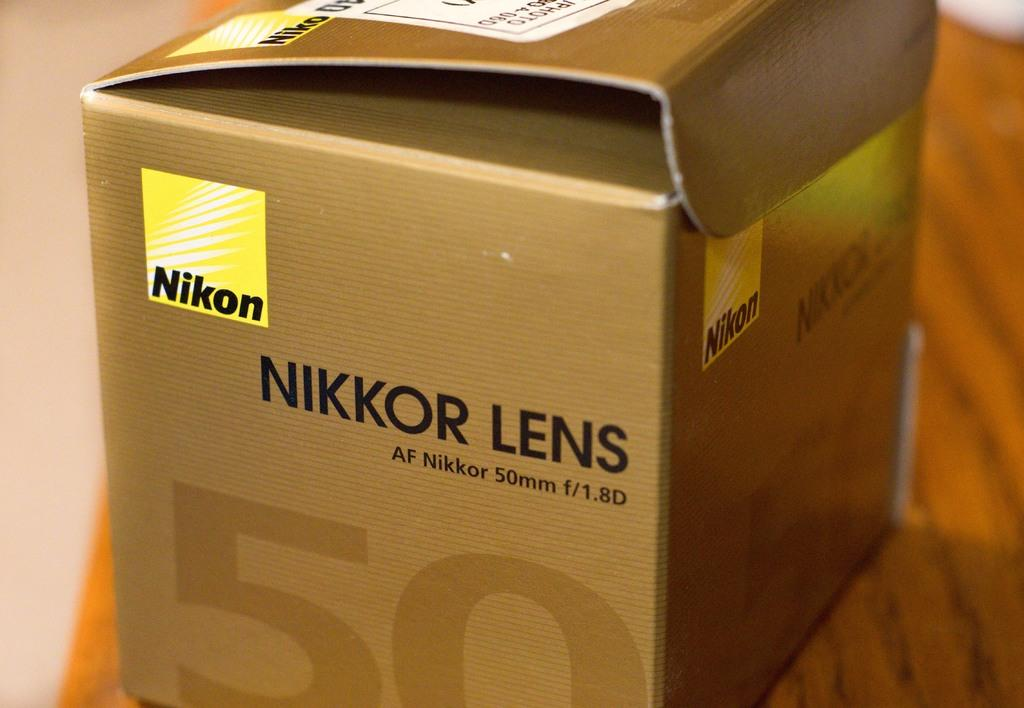<image>
Present a compact description of the photo's key features. The brown cardboard box contain a nikon product. 